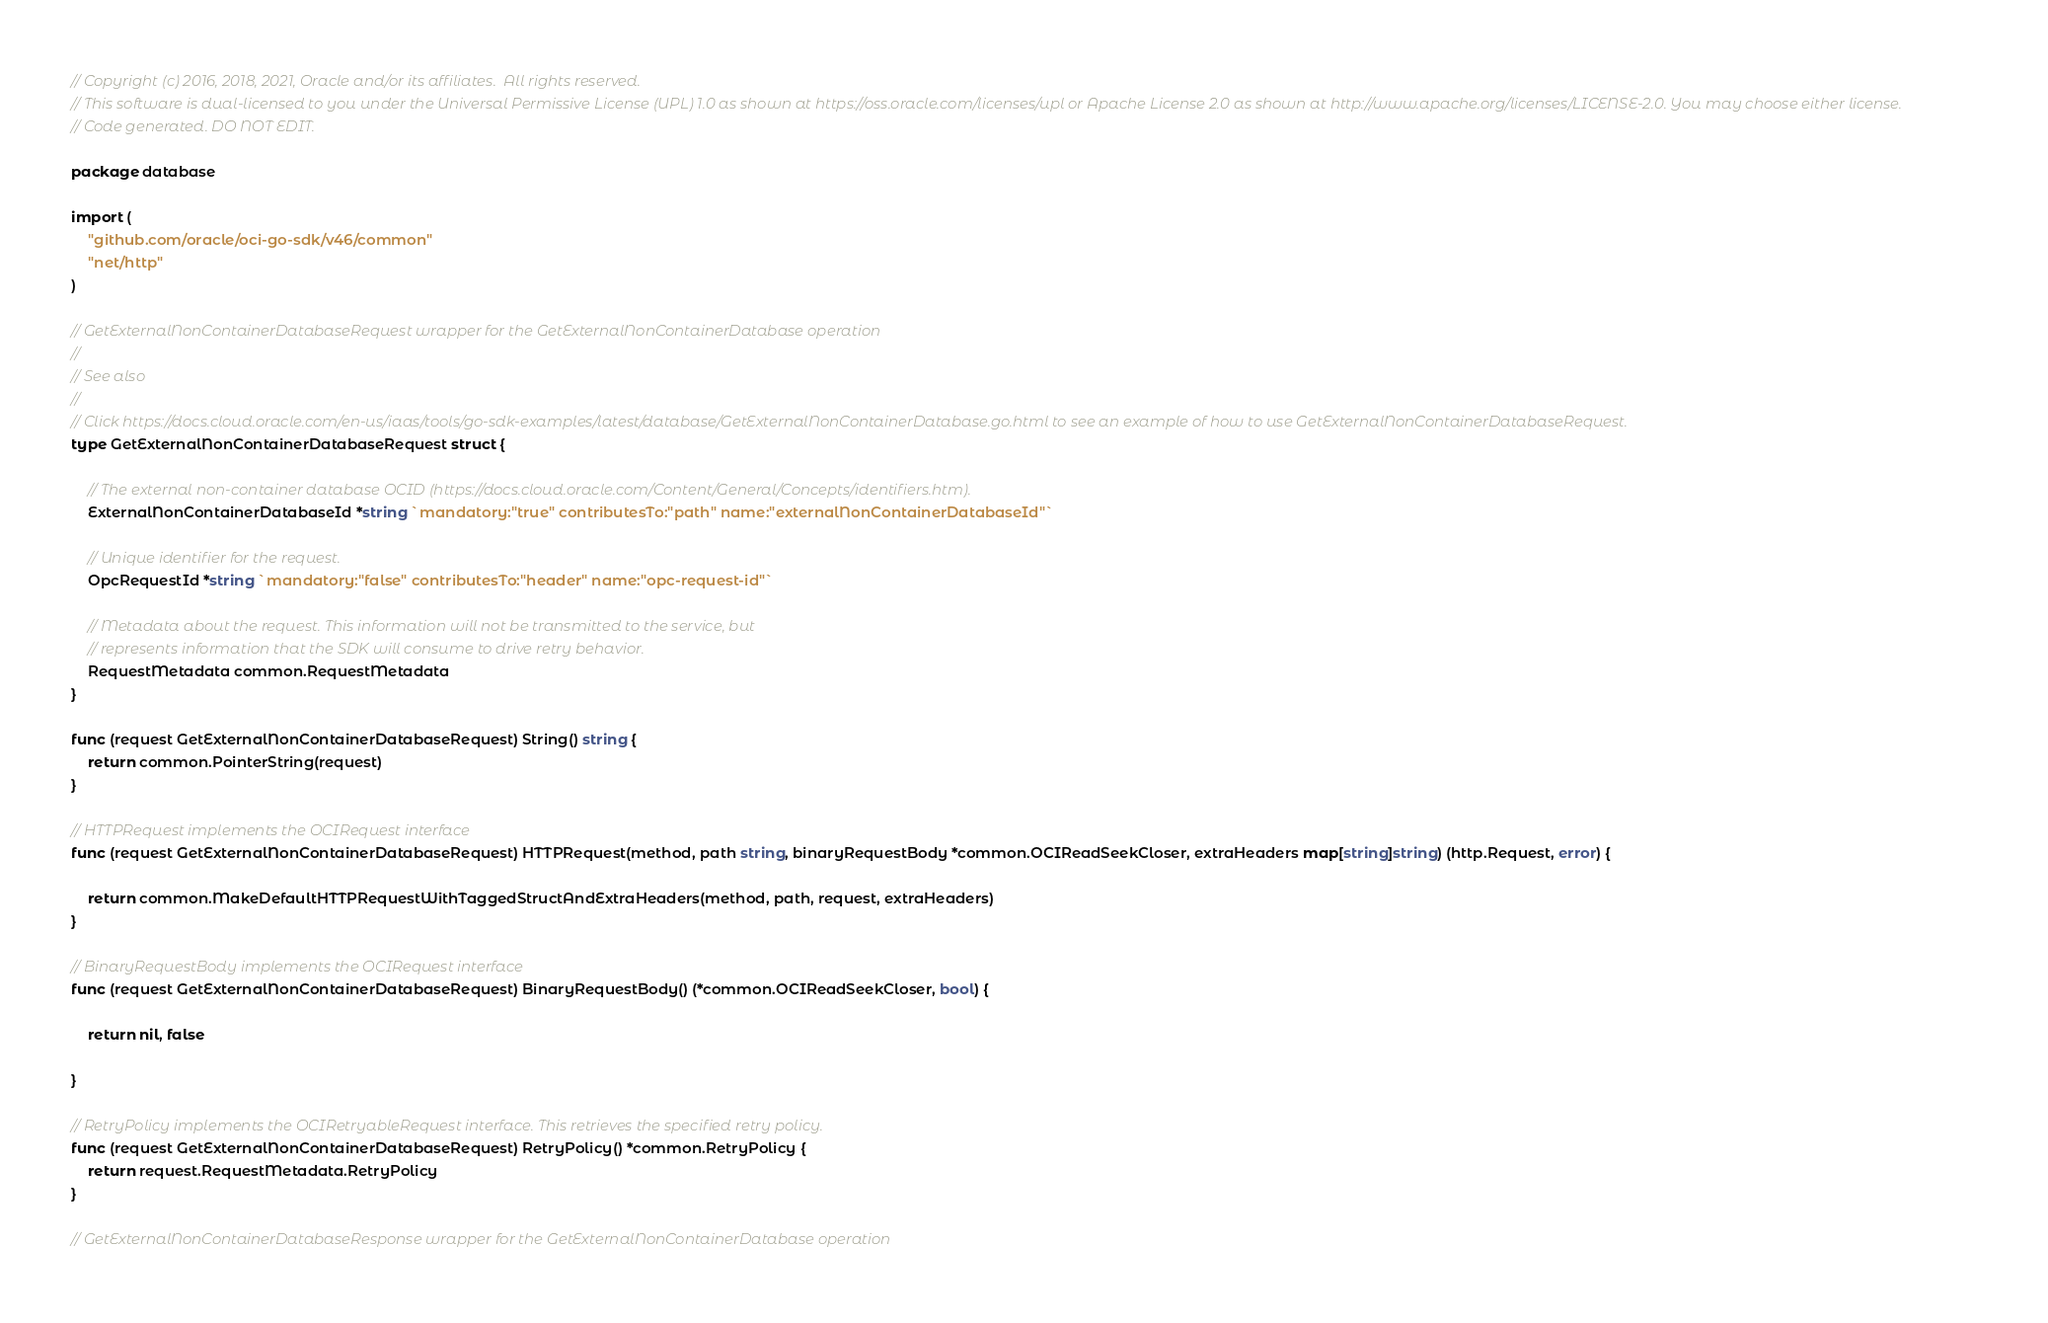Convert code to text. <code><loc_0><loc_0><loc_500><loc_500><_Go_>// Copyright (c) 2016, 2018, 2021, Oracle and/or its affiliates.  All rights reserved.
// This software is dual-licensed to you under the Universal Permissive License (UPL) 1.0 as shown at https://oss.oracle.com/licenses/upl or Apache License 2.0 as shown at http://www.apache.org/licenses/LICENSE-2.0. You may choose either license.
// Code generated. DO NOT EDIT.

package database

import (
	"github.com/oracle/oci-go-sdk/v46/common"
	"net/http"
)

// GetExternalNonContainerDatabaseRequest wrapper for the GetExternalNonContainerDatabase operation
//
// See also
//
// Click https://docs.cloud.oracle.com/en-us/iaas/tools/go-sdk-examples/latest/database/GetExternalNonContainerDatabase.go.html to see an example of how to use GetExternalNonContainerDatabaseRequest.
type GetExternalNonContainerDatabaseRequest struct {

	// The external non-container database OCID (https://docs.cloud.oracle.com/Content/General/Concepts/identifiers.htm).
	ExternalNonContainerDatabaseId *string `mandatory:"true" contributesTo:"path" name:"externalNonContainerDatabaseId"`

	// Unique identifier for the request.
	OpcRequestId *string `mandatory:"false" contributesTo:"header" name:"opc-request-id"`

	// Metadata about the request. This information will not be transmitted to the service, but
	// represents information that the SDK will consume to drive retry behavior.
	RequestMetadata common.RequestMetadata
}

func (request GetExternalNonContainerDatabaseRequest) String() string {
	return common.PointerString(request)
}

// HTTPRequest implements the OCIRequest interface
func (request GetExternalNonContainerDatabaseRequest) HTTPRequest(method, path string, binaryRequestBody *common.OCIReadSeekCloser, extraHeaders map[string]string) (http.Request, error) {

	return common.MakeDefaultHTTPRequestWithTaggedStructAndExtraHeaders(method, path, request, extraHeaders)
}

// BinaryRequestBody implements the OCIRequest interface
func (request GetExternalNonContainerDatabaseRequest) BinaryRequestBody() (*common.OCIReadSeekCloser, bool) {

	return nil, false

}

// RetryPolicy implements the OCIRetryableRequest interface. This retrieves the specified retry policy.
func (request GetExternalNonContainerDatabaseRequest) RetryPolicy() *common.RetryPolicy {
	return request.RequestMetadata.RetryPolicy
}

// GetExternalNonContainerDatabaseResponse wrapper for the GetExternalNonContainerDatabase operation</code> 